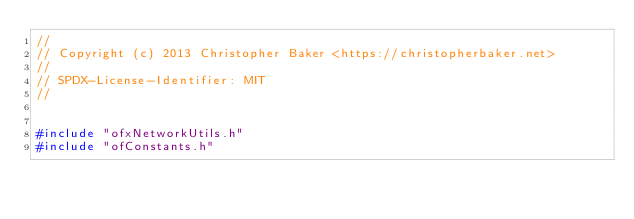Convert code to text. <code><loc_0><loc_0><loc_500><loc_500><_C++_>//
// Copyright (c) 2013 Christopher Baker <https://christopherbaker.net>
//
// SPDX-License-Identifier:	MIT
//


#include "ofxNetworkUtils.h"
#include "ofConstants.h"
</code> 